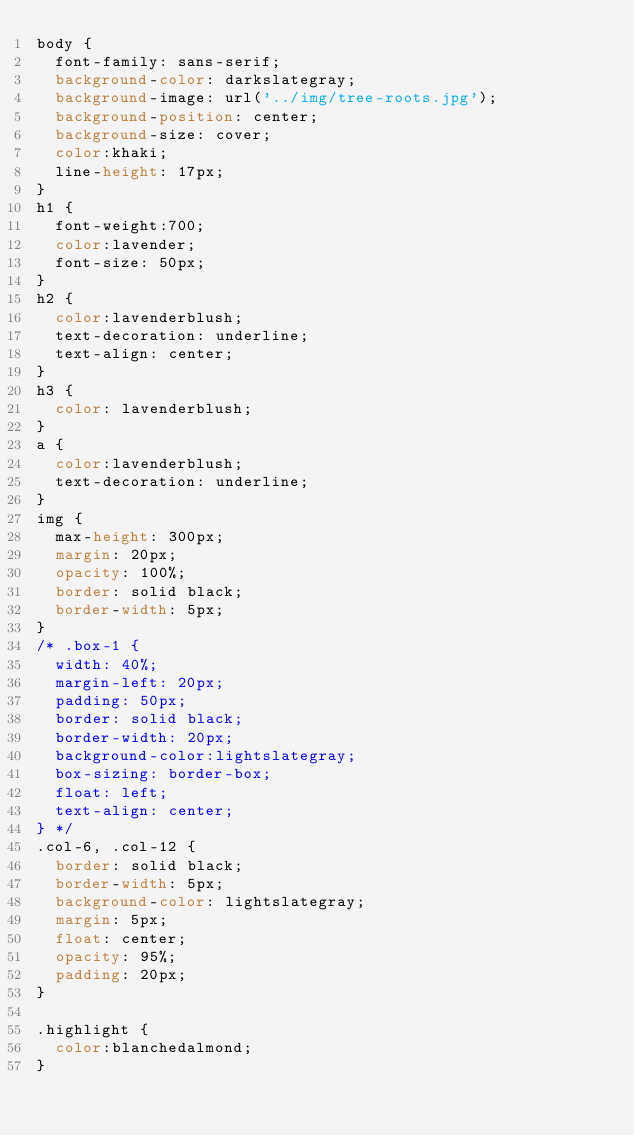Convert code to text. <code><loc_0><loc_0><loc_500><loc_500><_CSS_>body {
  font-family: sans-serif;
  background-color: darkslategray;
  background-image: url('../img/tree-roots.jpg');
  background-position: center;
  background-size: cover;
  color:khaki;
  line-height: 17px;
}
h1 {
  font-weight:700;
  color:lavender;
  font-size: 50px;
}
h2 {
  color:lavenderblush;
  text-decoration: underline;
  text-align: center;
}
h3 {
  color: lavenderblush;
}
a {
  color:lavenderblush;
  text-decoration: underline;
}
img {
  max-height: 300px;
  margin: 20px;
  opacity: 100%;
  border: solid black;
  border-width: 5px;
}
/* .box-1 {
  width: 40%;
  margin-left: 20px;
  padding: 50px;
  border: solid black;
  border-width: 20px;
  background-color:lightslategray;
  box-sizing: border-box;
  float: left;
  text-align: center;
} */
.col-6, .col-12 {
  border: solid black;
  border-width: 5px;
  background-color: lightslategray;
  margin: 5px;
  float: center;
  opacity: 95%;
  padding: 20px;
}

.highlight {
  color:blanchedalmond;
}
</code> 